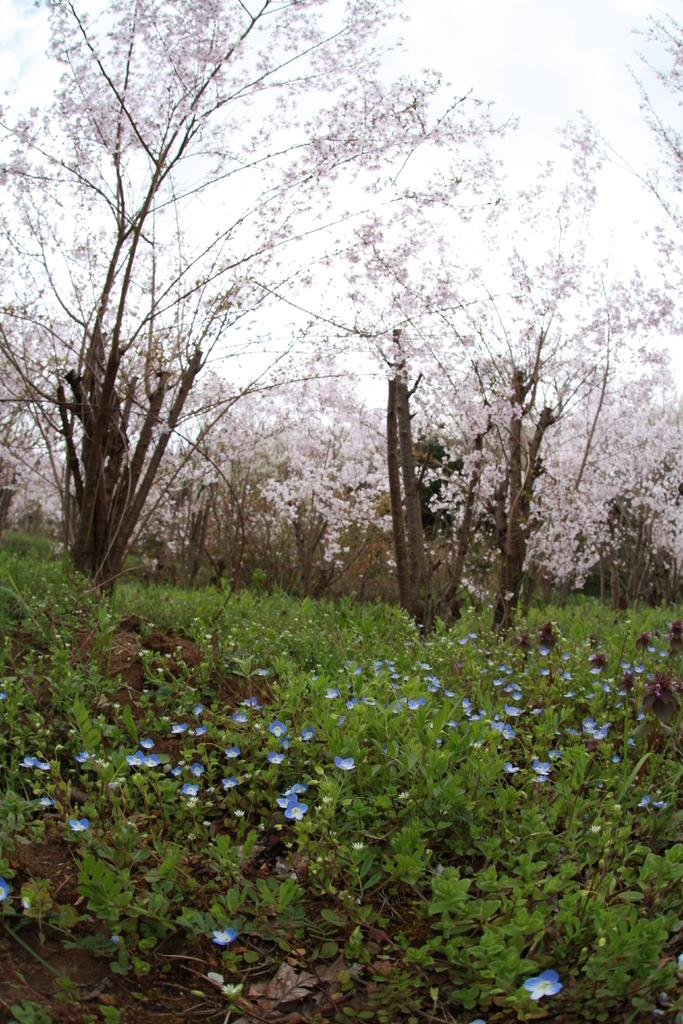Where was the picture taken? The picture was clicked outside. What can be seen in the foreground of the image? There are plants and flowers in the foreground of the image. What is visible in the background of the image? There is sky and trees visible in the background of the image. What event is being celebrated in the picture? There is no event being celebrated in the picture; it simply shows plants, flowers, sky, and trees. What is the limit of the picture's frame? The limit of the picture's frame is determined by the photographer's choice of composition and cannot be definitively answered from the given facts. 